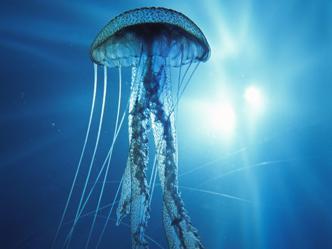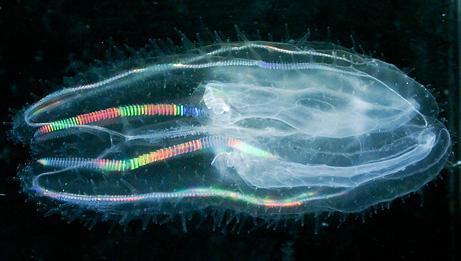The first image is the image on the left, the second image is the image on the right. Considering the images on both sides, is "One jellyfish has long tentacles." valid? Answer yes or no. Yes. The first image is the image on the left, the second image is the image on the right. Assess this claim about the two images: "there are two jellyfish in the image pair". Correct or not? Answer yes or no. Yes. 